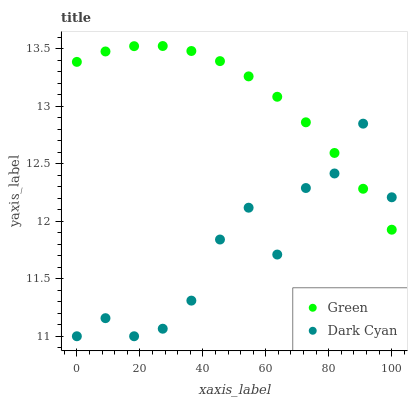Does Dark Cyan have the minimum area under the curve?
Answer yes or no. Yes. Does Green have the maximum area under the curve?
Answer yes or no. Yes. Does Green have the minimum area under the curve?
Answer yes or no. No. Is Green the smoothest?
Answer yes or no. Yes. Is Dark Cyan the roughest?
Answer yes or no. Yes. Is Green the roughest?
Answer yes or no. No. Does Dark Cyan have the lowest value?
Answer yes or no. Yes. Does Green have the lowest value?
Answer yes or no. No. Does Green have the highest value?
Answer yes or no. Yes. Does Dark Cyan intersect Green?
Answer yes or no. Yes. Is Dark Cyan less than Green?
Answer yes or no. No. Is Dark Cyan greater than Green?
Answer yes or no. No. 